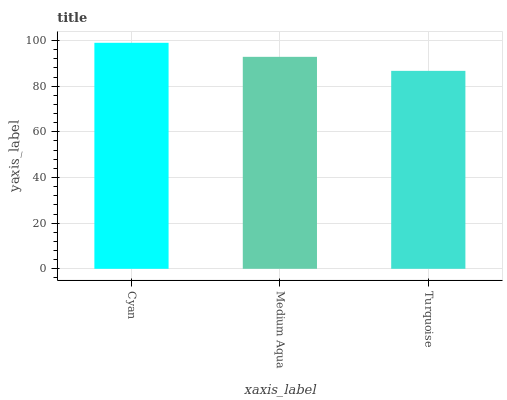Is Medium Aqua the minimum?
Answer yes or no. No. Is Medium Aqua the maximum?
Answer yes or no. No. Is Cyan greater than Medium Aqua?
Answer yes or no. Yes. Is Medium Aqua less than Cyan?
Answer yes or no. Yes. Is Medium Aqua greater than Cyan?
Answer yes or no. No. Is Cyan less than Medium Aqua?
Answer yes or no. No. Is Medium Aqua the high median?
Answer yes or no. Yes. Is Medium Aqua the low median?
Answer yes or no. Yes. Is Turquoise the high median?
Answer yes or no. No. Is Turquoise the low median?
Answer yes or no. No. 